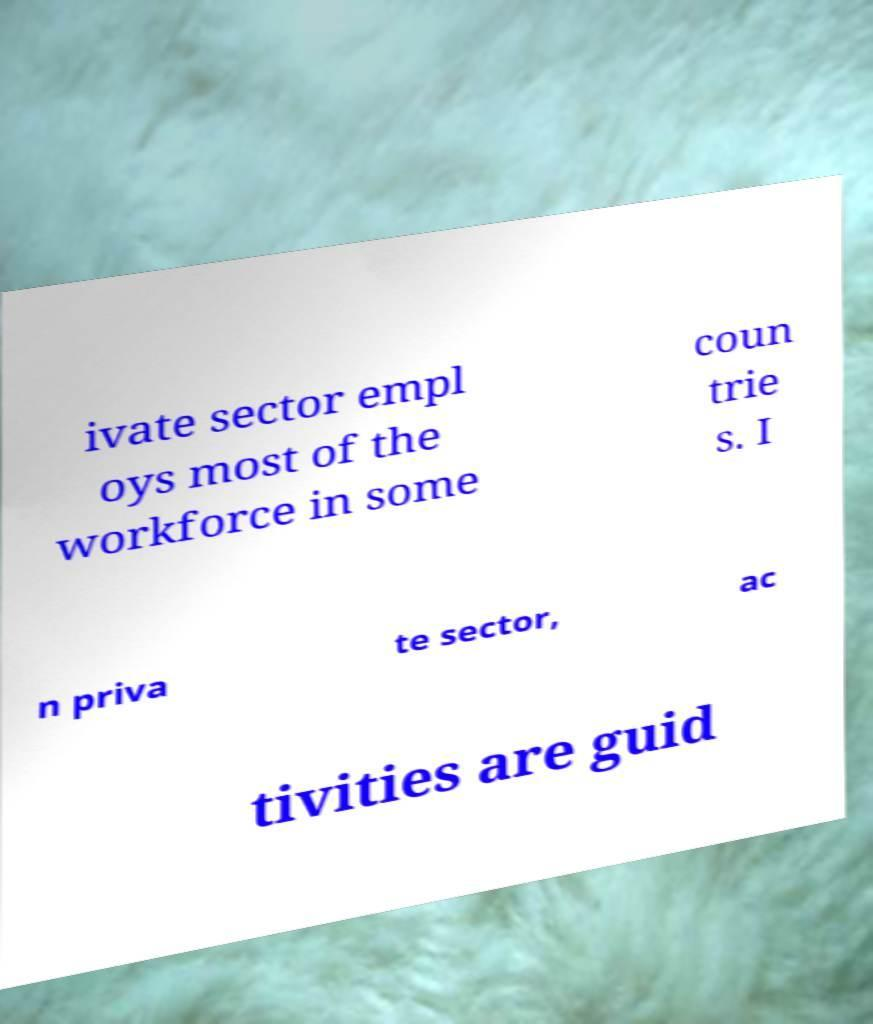I need the written content from this picture converted into text. Can you do that? ivate sector empl oys most of the workforce in some coun trie s. I n priva te sector, ac tivities are guid 